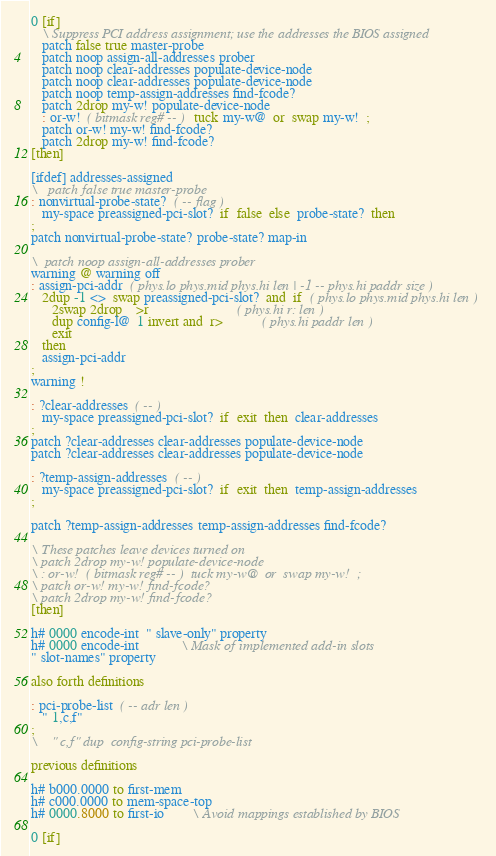Convert code to text. <code><loc_0><loc_0><loc_500><loc_500><_Forth_>
0 [if]
   \ Suppress PCI address assignment; use the addresses the BIOS assigned
   patch false true master-probe
   patch noop assign-all-addresses prober
   patch noop clear-addresses populate-device-node
   patch noop clear-addresses populate-device-node
   patch noop temp-assign-addresses find-fcode?
   patch 2drop my-w! populate-device-node
   : or-w!  ( bitmask reg# -- )  tuck my-w@  or  swap my-w!  ;
   patch or-w! my-w! find-fcode?
   patch 2drop my-w! find-fcode?
[then]

[ifdef] addresses-assigned
\   patch false true master-probe
: nonvirtual-probe-state?  ( -- flag )
   my-space preassigned-pci-slot?  if  false  else  probe-state?  then
;
patch nonvirtual-probe-state? probe-state? map-in

\  patch noop assign-all-addresses prober
warning @ warning off
: assign-pci-addr  ( phys.lo phys.mid phys.hi len | -1 -- phys.hi paddr size )
   2dup -1 <>  swap preassigned-pci-slot?  and  if  ( phys.lo phys.mid phys.hi len )
      2swap 2drop    >r                         ( phys.hi r: len )
      dup config-l@  1 invert and  r>           ( phys.hi paddr len )
      exit
   then
   assign-pci-addr
;
warning !

: ?clear-addresses  ( -- )
   my-space preassigned-pci-slot?  if  exit  then  clear-addresses
;
patch ?clear-addresses clear-addresses populate-device-node
patch ?clear-addresses clear-addresses populate-device-node

: ?temp-assign-addresses  ( -- )
   my-space preassigned-pci-slot?  if  exit  then  temp-assign-addresses
;

patch ?temp-assign-addresses temp-assign-addresses find-fcode?

\ These patches leave devices turned on
\ patch 2drop my-w! populate-device-node
\ : or-w!  ( bitmask reg# -- )  tuck my-w@  or  swap my-w!  ;
\ patch or-w! my-w! find-fcode?
\ patch 2drop my-w! find-fcode?
[then]

h# 0000 encode-int  " slave-only" property
h# 0000 encode-int			\ Mask of implemented add-in slots
" slot-names" property

also forth definitions

: pci-probe-list  ( -- adr len )
   " 1,c,f"
;
\    " c,f" dup  config-string pci-probe-list

previous definitions

h# b000.0000 to first-mem
h# c000.0000 to mem-space-top
h# 0000.8000 to first-io		\ Avoid mappings established by BIOS

0 [if]</code> 